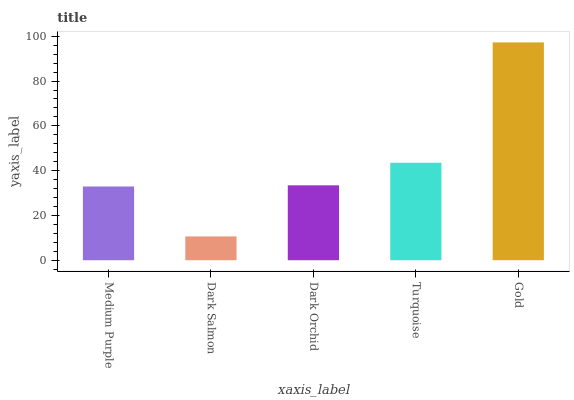Is Dark Salmon the minimum?
Answer yes or no. Yes. Is Gold the maximum?
Answer yes or no. Yes. Is Dark Orchid the minimum?
Answer yes or no. No. Is Dark Orchid the maximum?
Answer yes or no. No. Is Dark Orchid greater than Dark Salmon?
Answer yes or no. Yes. Is Dark Salmon less than Dark Orchid?
Answer yes or no. Yes. Is Dark Salmon greater than Dark Orchid?
Answer yes or no. No. Is Dark Orchid less than Dark Salmon?
Answer yes or no. No. Is Dark Orchid the high median?
Answer yes or no. Yes. Is Dark Orchid the low median?
Answer yes or no. Yes. Is Gold the high median?
Answer yes or no. No. Is Dark Salmon the low median?
Answer yes or no. No. 